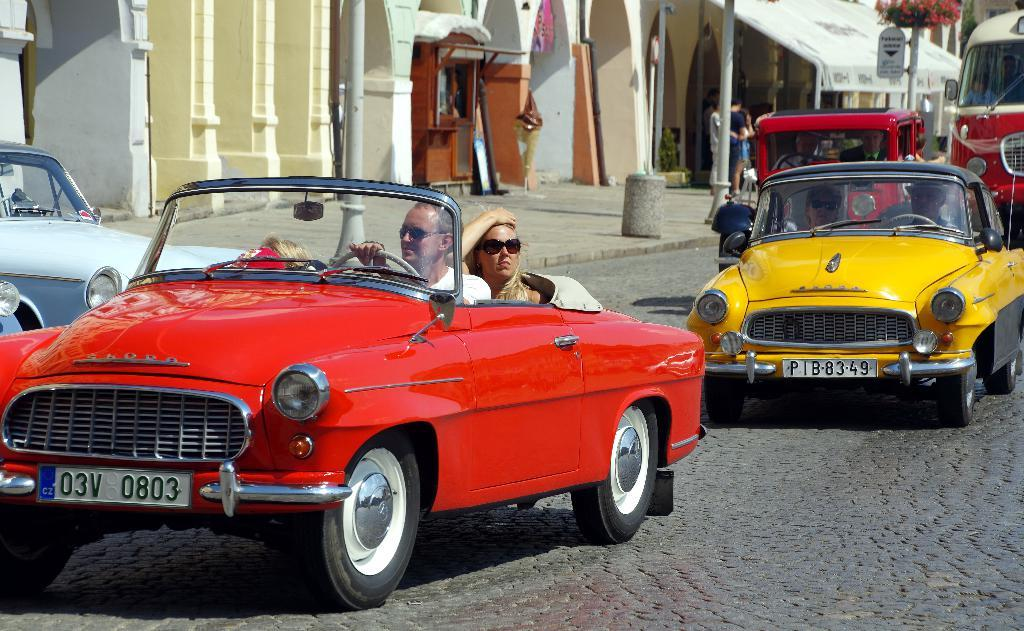What are the persons in the image doing? There are persons travelling in vehicles on the road and some persons standing. What can be seen in the image besides the persons? There are poles and a building in the background of the image. What type of chain can be seen hanging from the building in the image? There is no chain hanging from the building in the image. How many holes are visible in the road in the image? There are no holes visible in the road in the image. 